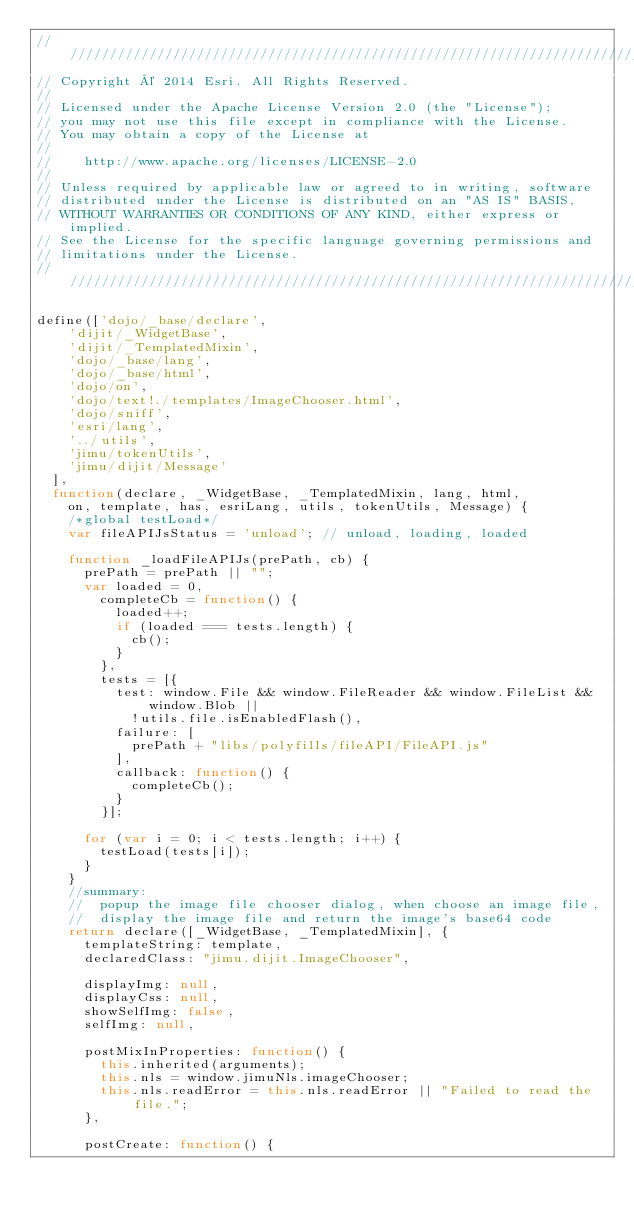<code> <loc_0><loc_0><loc_500><loc_500><_JavaScript_>///////////////////////////////////////////////////////////////////////////
// Copyright © 2014 Esri. All Rights Reserved.
//
// Licensed under the Apache License Version 2.0 (the "License");
// you may not use this file except in compliance with the License.
// You may obtain a copy of the License at
//
//    http://www.apache.org/licenses/LICENSE-2.0
//
// Unless required by applicable law or agreed to in writing, software
// distributed under the License is distributed on an "AS IS" BASIS,
// WITHOUT WARRANTIES OR CONDITIONS OF ANY KIND, either express or implied.
// See the License for the specific language governing permissions and
// limitations under the License.
///////////////////////////////////////////////////////////////////////////

define(['dojo/_base/declare',
    'dijit/_WidgetBase',
    'dijit/_TemplatedMixin',
    'dojo/_base/lang',
    'dojo/_base/html',
    'dojo/on',
    'dojo/text!./templates/ImageChooser.html',
    'dojo/sniff',
    'esri/lang',
    '../utils',
    'jimu/tokenUtils',
    'jimu/dijit/Message'
  ],
  function(declare, _WidgetBase, _TemplatedMixin, lang, html,
    on, template, has, esriLang, utils, tokenUtils, Message) {
    /*global testLoad*/
    var fileAPIJsStatus = 'unload'; // unload, loading, loaded

    function _loadFileAPIJs(prePath, cb) {
      prePath = prePath || "";
      var loaded = 0,
        completeCb = function() {
          loaded++;
          if (loaded === tests.length) {
            cb();
          }
        },
        tests = [{
          test: window.File && window.FileReader && window.FileList && window.Blob ||
            !utils.file.isEnabledFlash(),
          failure: [
            prePath + "libs/polyfills/fileAPI/FileAPI.js"
          ],
          callback: function() {
            completeCb();
          }
        }];

      for (var i = 0; i < tests.length; i++) {
        testLoad(tests[i]);
      }
    }
    //summary:
    //  popup the image file chooser dialog, when choose an image file,
    //  display the image file and return the image's base64 code
    return declare([_WidgetBase, _TemplatedMixin], {
      templateString: template,
      declaredClass: "jimu.dijit.ImageChooser",

      displayImg: null,
      displayCss: null,
      showSelfImg: false,
      selfImg: null,

      postMixInProperties: function() {
        this.inherited(arguments);
        this.nls = window.jimuNls.imageChooser;
        this.nls.readError = this.nls.readError || "Failed to read the file.";
      },

      postCreate: function() {</code> 